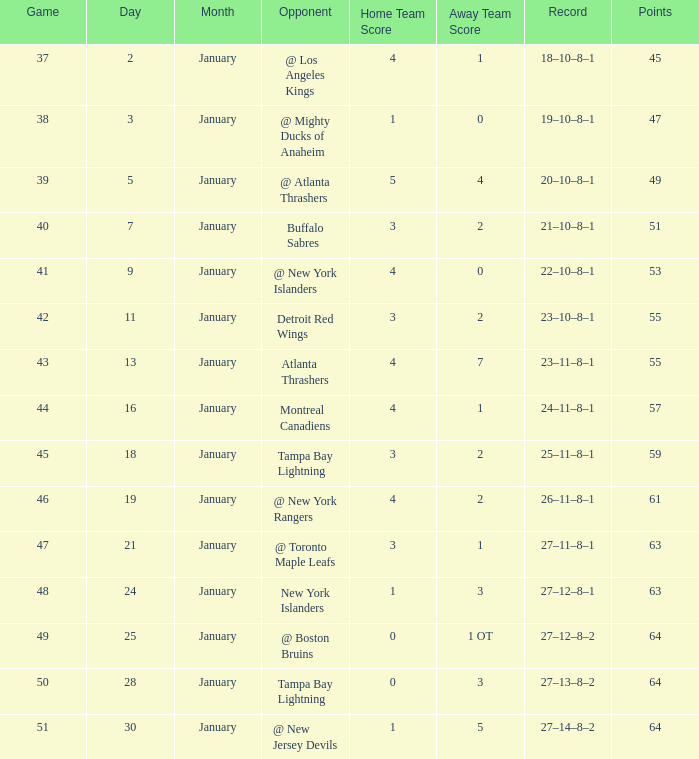Which score consists of 64 points and 49 games? 0–1 OT. Could you help me parse every detail presented in this table? {'header': ['Game', 'Day', 'Month', 'Opponent', 'Home Team Score', 'Away Team Score', 'Record', 'Points'], 'rows': [['37', '2', 'January', '@ Los Angeles Kings', '4', '1', '18–10–8–1', '45'], ['38', '3', 'January', '@ Mighty Ducks of Anaheim', '1', '0', '19–10–8–1', '47'], ['39', '5', 'January', '@ Atlanta Thrashers', '5', '4', '20–10–8–1', '49'], ['40', '7', 'January', 'Buffalo Sabres', '3', '2', '21–10–8–1', '51'], ['41', '9', 'January', '@ New York Islanders', '4', '0', '22–10–8–1', '53'], ['42', '11', 'January', 'Detroit Red Wings', '3', '2', '23–10–8–1', '55'], ['43', '13', 'January', 'Atlanta Thrashers', '4', '7', '23–11–8–1', '55'], ['44', '16', 'January', 'Montreal Canadiens', '4', '1', '24–11–8–1', '57'], ['45', '18', 'January', 'Tampa Bay Lightning', '3', '2', '25–11–8–1', '59'], ['46', '19', 'January', '@ New York Rangers', '4', '2', '26–11–8–1', '61'], ['47', '21', 'January', '@ Toronto Maple Leafs', '3', '1', '27–11–8–1', '63'], ['48', '24', 'January', 'New York Islanders', '1', '3', '27–12–8–1', '63'], ['49', '25', 'January', '@ Boston Bruins', '0', '1 OT', '27–12–8–2', '64'], ['50', '28', 'January', 'Tampa Bay Lightning', '0', '3', '27–13–8–2', '64'], ['51', '30', 'January', '@ New Jersey Devils', '1', '5', '27–14–8–2', '64']]} 